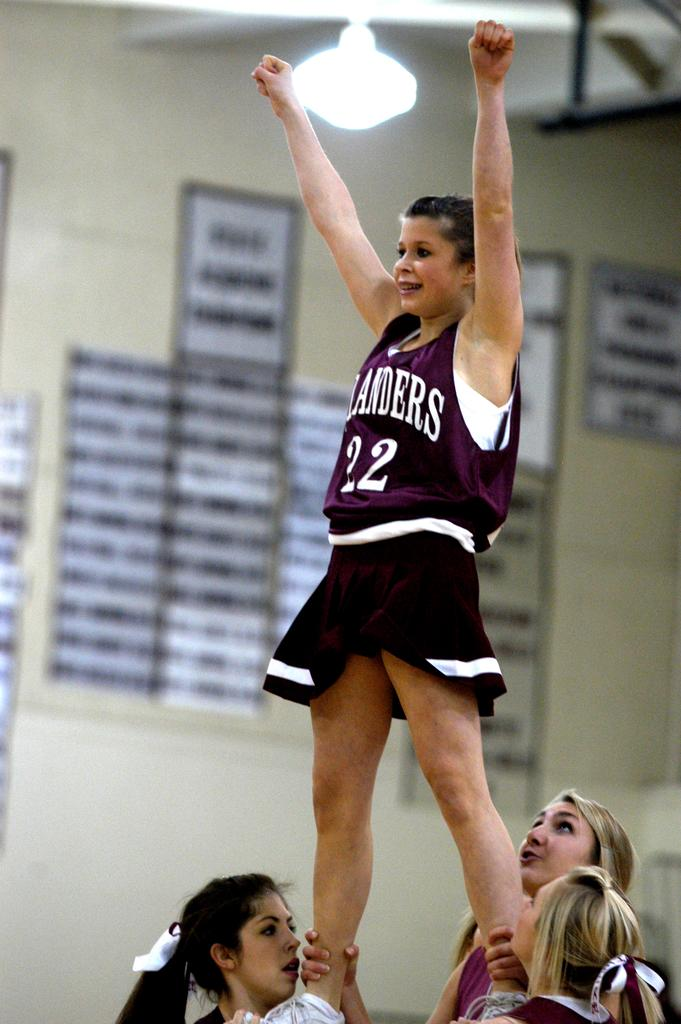What are the women in the image doing to help the other woman? The women are holding the legs of another woman in the image to help her stand. What can be seen on the wall in the image? There are posters attached to the wall in the image. What is the source of light at the top of the image? There is a lamp at the top of the image. What type of elbow is visible in the image? There is no elbow visible in the image. Is there a lawyer present in the image? There is no lawyer present in the image. 